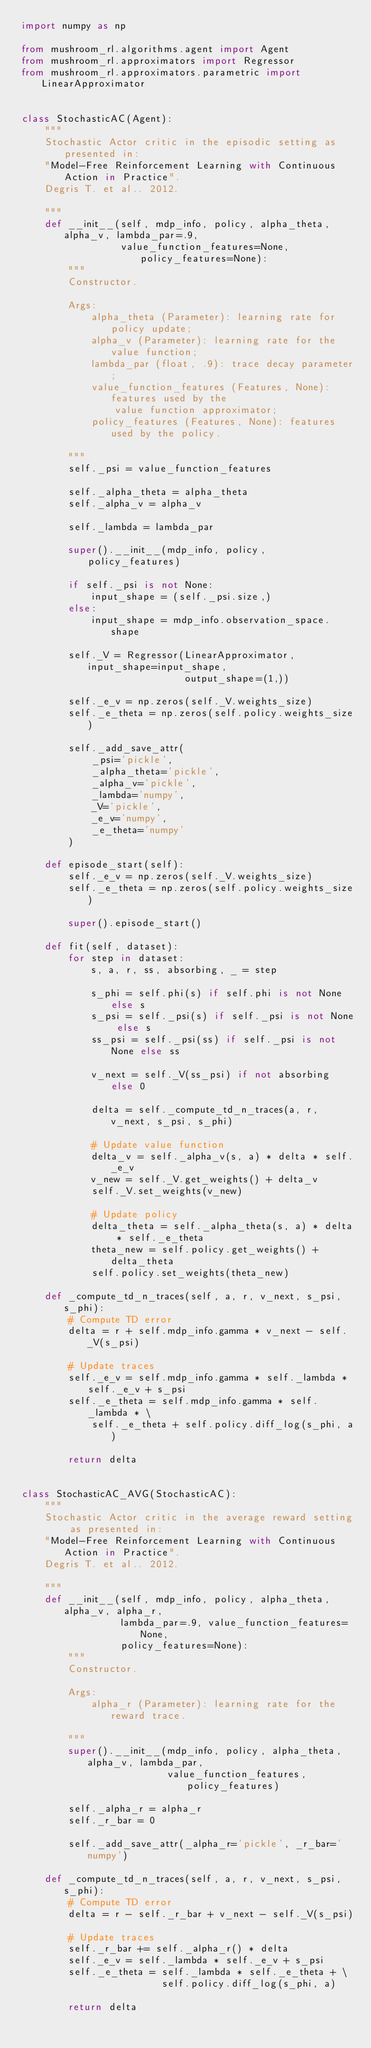Convert code to text. <code><loc_0><loc_0><loc_500><loc_500><_Python_>import numpy as np

from mushroom_rl.algorithms.agent import Agent
from mushroom_rl.approximators import Regressor
from mushroom_rl.approximators.parametric import LinearApproximator


class StochasticAC(Agent):
    """
    Stochastic Actor critic in the episodic setting as presented in:
    "Model-Free Reinforcement Learning with Continuous Action in Practice".
    Degris T. et al.. 2012.

    """
    def __init__(self, mdp_info, policy, alpha_theta, alpha_v, lambda_par=.9,
                 value_function_features=None, policy_features=None):
        """
        Constructor.

        Args:
            alpha_theta (Parameter): learning rate for policy update;
            alpha_v (Parameter): learning rate for the value function;
            lambda_par (float, .9): trace decay parameter;
            value_function_features (Features, None): features used by the
                value function approximator;
            policy_features (Features, None): features used by the policy.

        """
        self._psi = value_function_features

        self._alpha_theta = alpha_theta
        self._alpha_v = alpha_v

        self._lambda = lambda_par

        super().__init__(mdp_info, policy, policy_features)

        if self._psi is not None:
            input_shape = (self._psi.size,)
        else:
            input_shape = mdp_info.observation_space.shape

        self._V = Regressor(LinearApproximator, input_shape=input_shape,
                            output_shape=(1,))

        self._e_v = np.zeros(self._V.weights_size)
        self._e_theta = np.zeros(self.policy.weights_size)

        self._add_save_attr(
            _psi='pickle',
            _alpha_theta='pickle',
            _alpha_v='pickle',
            _lambda='numpy',
            _V='pickle',
            _e_v='numpy',
            _e_theta='numpy'
        )

    def episode_start(self):
        self._e_v = np.zeros(self._V.weights_size)
        self._e_theta = np.zeros(self.policy.weights_size)

        super().episode_start()

    def fit(self, dataset):
        for step in dataset:
            s, a, r, ss, absorbing, _ = step

            s_phi = self.phi(s) if self.phi is not None else s
            s_psi = self._psi(s) if self._psi is not None else s
            ss_psi = self._psi(ss) if self._psi is not None else ss

            v_next = self._V(ss_psi) if not absorbing else 0

            delta = self._compute_td_n_traces(a, r, v_next, s_psi, s_phi)

            # Update value function
            delta_v = self._alpha_v(s, a) * delta * self._e_v
            v_new = self._V.get_weights() + delta_v
            self._V.set_weights(v_new)

            # Update policy
            delta_theta = self._alpha_theta(s, a) * delta * self._e_theta
            theta_new = self.policy.get_weights() + delta_theta
            self.policy.set_weights(theta_new)

    def _compute_td_n_traces(self, a, r, v_next, s_psi, s_phi):
        # Compute TD error
        delta = r + self.mdp_info.gamma * v_next - self._V(s_psi)

        # Update traces
        self._e_v = self.mdp_info.gamma * self._lambda * self._e_v + s_psi
        self._e_theta = self.mdp_info.gamma * self._lambda * \
            self._e_theta + self.policy.diff_log(s_phi, a)

        return delta


class StochasticAC_AVG(StochasticAC):
    """
    Stochastic Actor critic in the average reward setting as presented in:
    "Model-Free Reinforcement Learning with Continuous Action in Practice".
    Degris T. et al.. 2012.

    """
    def __init__(self, mdp_info, policy, alpha_theta, alpha_v, alpha_r,
                 lambda_par=.9, value_function_features=None,
                 policy_features=None):
        """
        Constructor.

        Args:
            alpha_r (Parameter): learning rate for the reward trace.

        """
        super().__init__(mdp_info, policy, alpha_theta, alpha_v, lambda_par,
                         value_function_features, policy_features)

        self._alpha_r = alpha_r
        self._r_bar = 0

        self._add_save_attr(_alpha_r='pickle', _r_bar='numpy')

    def _compute_td_n_traces(self, a, r, v_next, s_psi, s_phi):
        # Compute TD error
        delta = r - self._r_bar + v_next - self._V(s_psi)

        # Update traces
        self._r_bar += self._alpha_r() * delta
        self._e_v = self._lambda * self._e_v + s_psi
        self._e_theta = self._lambda * self._e_theta + \
                        self.policy.diff_log(s_phi, a)

        return delta
</code> 